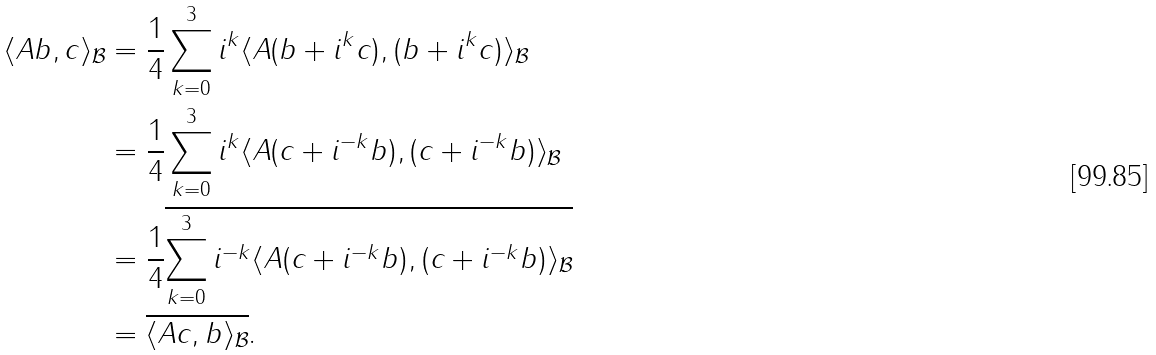<formula> <loc_0><loc_0><loc_500><loc_500>\langle A b , c \rangle _ { \mathcal { B } } & = \frac { 1 } { 4 } \sum _ { k = 0 } ^ { 3 } i ^ { k } \langle A ( b + i ^ { k } c ) , ( b + i ^ { k } c ) \rangle _ { \mathcal { B } } \\ & = \frac { 1 } { 4 } \sum _ { k = 0 } ^ { 3 } i ^ { k } \langle A ( c + i ^ { - k } b ) , ( c + i ^ { - k } b ) \rangle _ { \mathcal { B } } \\ & = \frac { 1 } { 4 } \overline { \sum _ { k = 0 } ^ { 3 } i ^ { - k } \langle A ( c + i ^ { - k } b ) , ( c + i ^ { - k } b ) \rangle _ { \mathcal { B } } } \\ & = \overline { \langle A c , b \rangle _ { \mathcal { B } } } .</formula> 